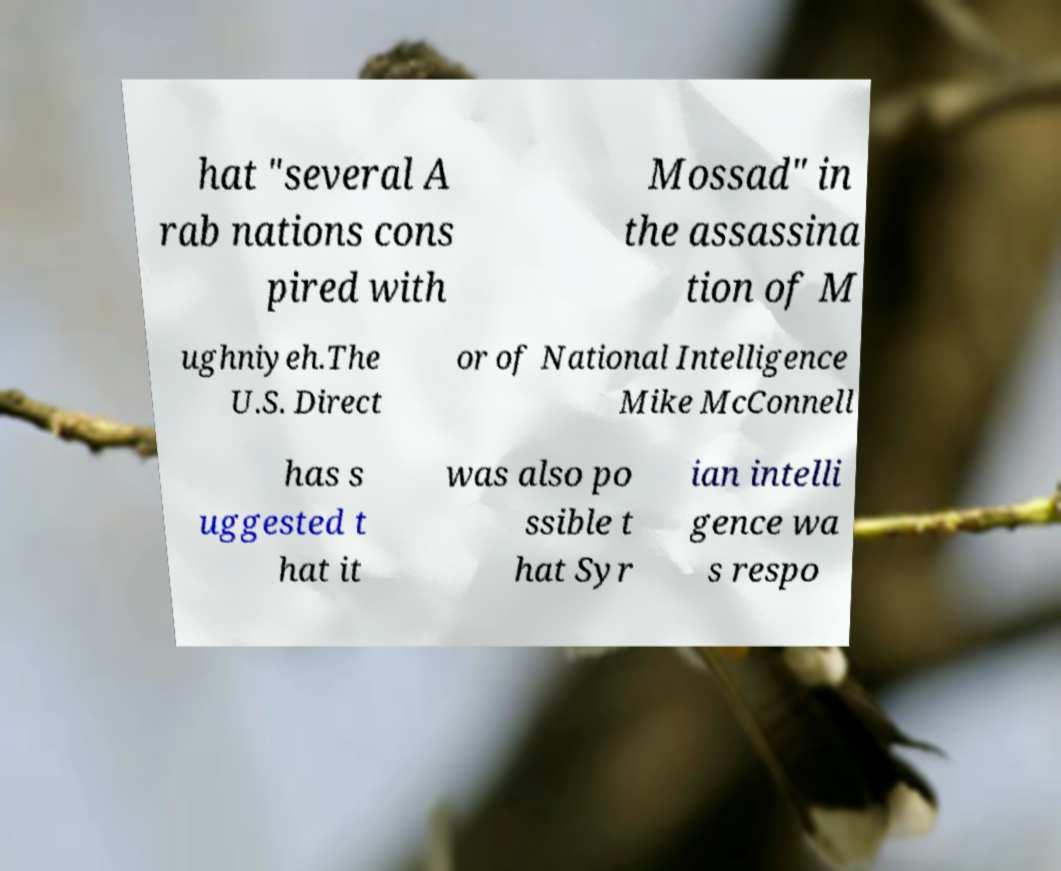Please identify and transcribe the text found in this image. hat "several A rab nations cons pired with Mossad" in the assassina tion of M ughniyeh.The U.S. Direct or of National Intelligence Mike McConnell has s uggested t hat it was also po ssible t hat Syr ian intelli gence wa s respo 